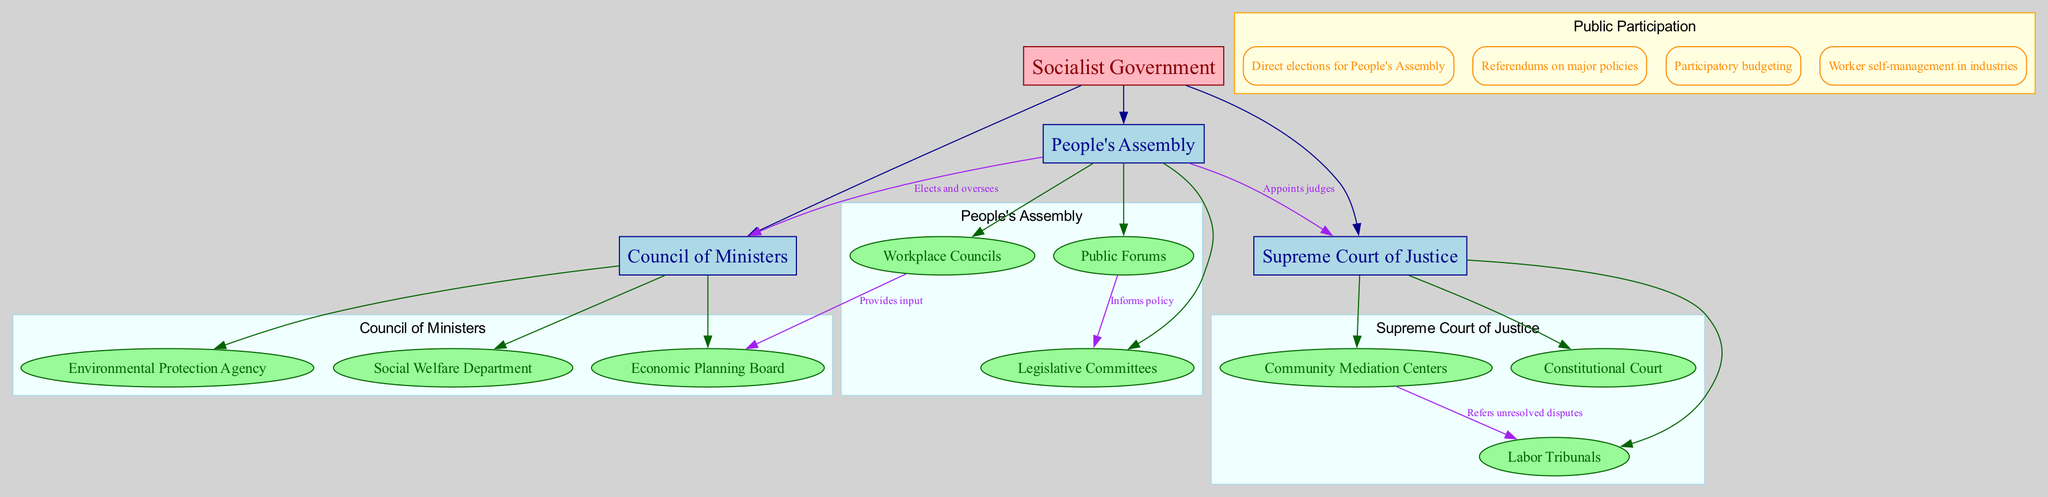What are the main branches of the organizational chart? The main branches are listed directly from the diagram, showing the top-level divisions of the government structure. They include "People's Assembly," "Council of Ministers," and "Supreme Court of Justice."
Answer: People's Assembly, Council of Ministers, Supreme Court of Justice How many sub-branches does the Council of Ministers have? By examining the sub-branches associated with the Council of Ministers in the diagram, we see it contains three directly listed sub-branches: "Economic Planning Board," "Social Welfare Department," and "Environmental Protection Agency."
Answer: 3 What role does the People's Assembly have over the Council of Ministers? The diagram shows a directed edge from "People's Assembly" to "Council of Ministers" with a label stating “Elects and oversees,” indicating the dominant role of the People's Assembly in this relationship.
Answer: Elects and oversees How does the Community Mediation Centers relate to the Labor Tribunals? The diagram indicates a connection labeled "Refers unresolved disputes" from "Community Mediation Centers" to "Labor Tribunals," suggesting a functional relationship where mediation efforts are directed towards the labor court system for unresolved cases.
Answer: Refers unresolved disputes Which entity provides input to the Economic Planning Board? The diagram shows that the "Workplace Councils" have a connection to the "Economic Planning Board," marked with the label "Provides input," illustrating their role in influencing economic planning.
Answer: Workplace Councils What mechanism allows for direct citizen influence on major government decisions? The diagram lists "Referendums on major policies" under public participation mechanisms, making it clear that this is a formal route for citizen input directly on significant issues governed by the socialist structure.
Answer: Referendums on major policies What is the purpose of the Public Forums? The diagram indicates that "Public Forums" are linked to "Legislative Committees" with the label "Informs policy," highlighting their role as a participatory platform for citizens to directly impact legislative processes.
Answer: Informs policy How many levels of judicial oversight are represented in the Supreme Court of Justice? The Supreme Court of Justice consists of three sub-branches: "Constitutional Court," "Labor Tribunals," and "Community Mediation Centers," indicating a three-tiered approach to judicial oversight and resolution.
Answer: 3 What method of budget allocation is included in public participation? From the public participation section of the diagram, “Participatory budgeting” is clearly listed, representing a democratic approach where citizens have a direct role in deciding how public funds are allocated.
Answer: Participatory budgeting 